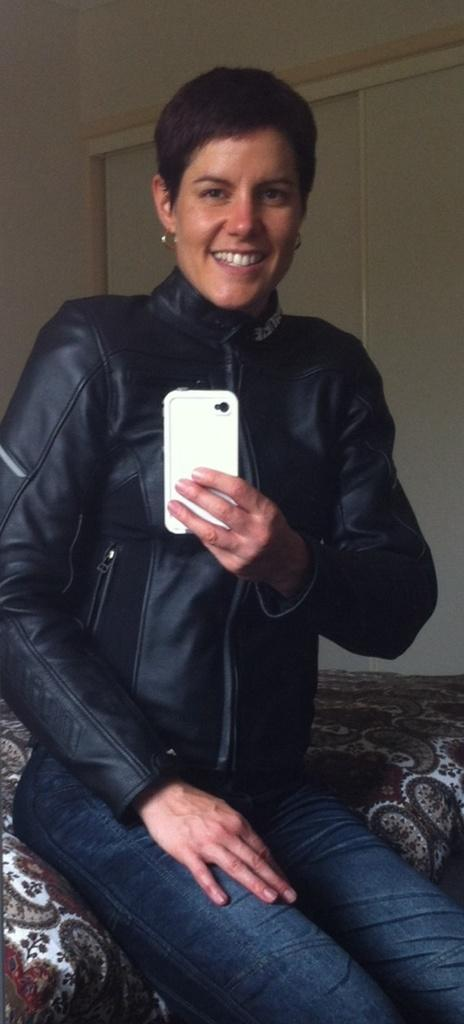Who is present in the image? There is a woman in the image. What is the woman doing in the image? The woman is sitting in a bed and taking a picture with a mobile phone. What can be seen in the background of the image? There is a wall in the background of the image. What type of reward is the woman receiving from the police in the image? There is no police or reward present in the image. The woman is simply taking a picture with her mobile phone while sitting in a bed. 